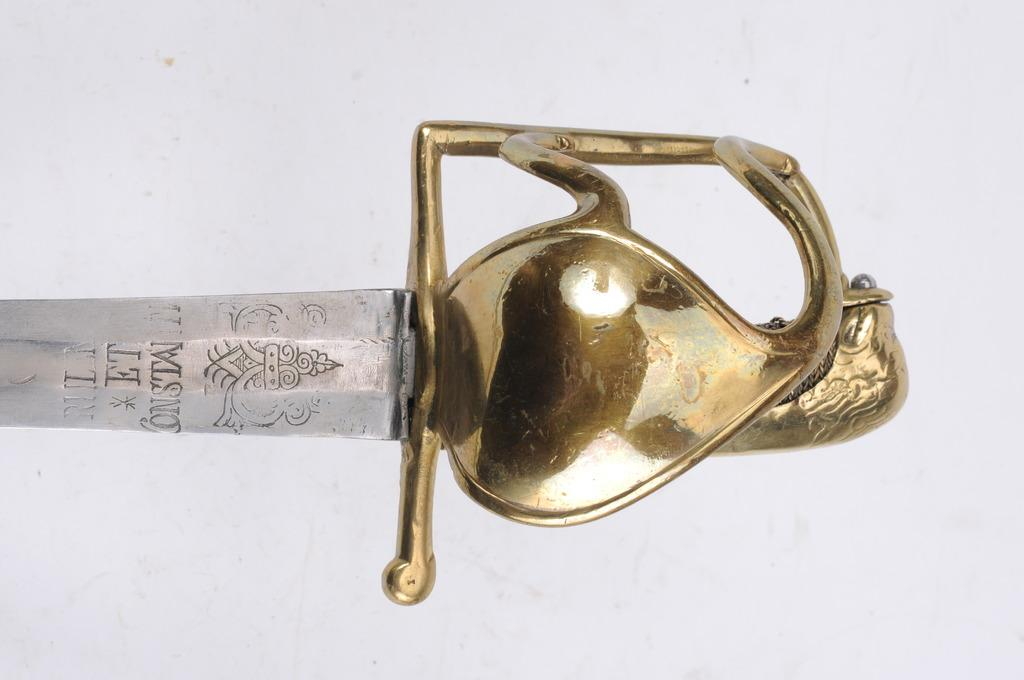What object can be seen in the image? There is a sword in the image. What color is present on the right side of the sword? The sword has a gold color on the right side. What type of fruit is being used to make a quince pie in the image? There is no fruit or pie present in the image; it only features a sword. 